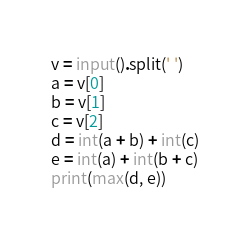Convert code to text. <code><loc_0><loc_0><loc_500><loc_500><_Python_>v = input().split(' ')
a = v[0]
b = v[1]
c = v[2]
d = int(a + b) + int(c)
e = int(a) + int(b + c)
print(max(d, e))</code> 